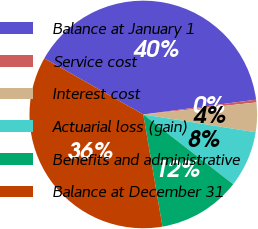Convert chart to OTSL. <chart><loc_0><loc_0><loc_500><loc_500><pie_chart><fcel>Balance at January 1<fcel>Service cost<fcel>Interest cost<fcel>Actuarial loss (gain)<fcel>Benefits and administrative<fcel>Balance at December 31<nl><fcel>39.72%<fcel>0.39%<fcel>4.19%<fcel>8.0%<fcel>11.8%<fcel>35.91%<nl></chart> 